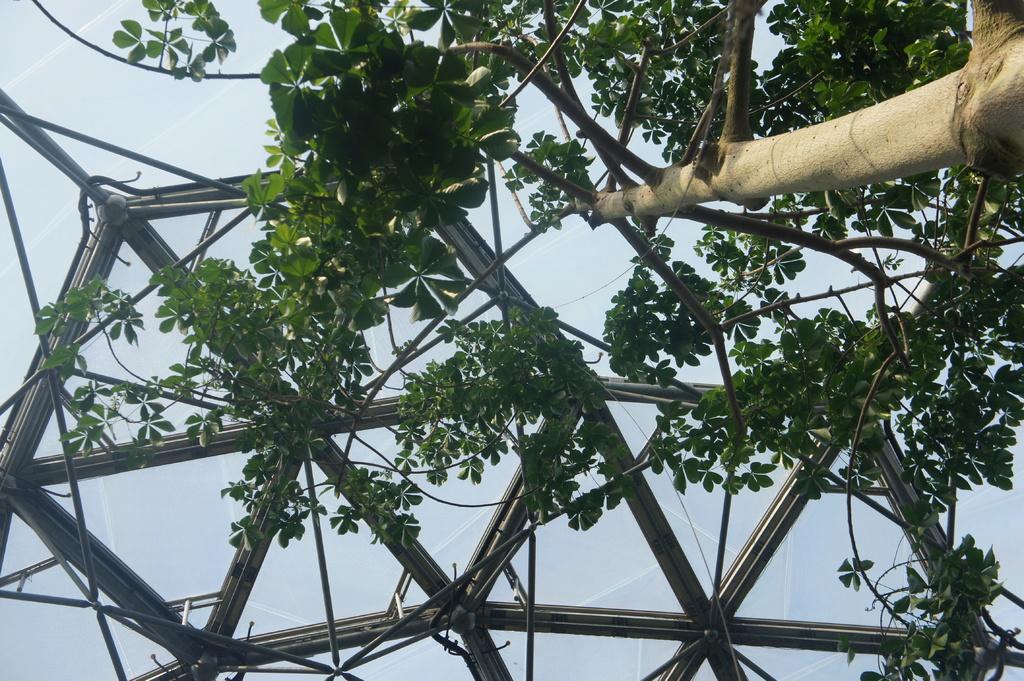Can you describe this image briefly? There is a tree on the right side of this image and it seems like there is a tent in the background. 